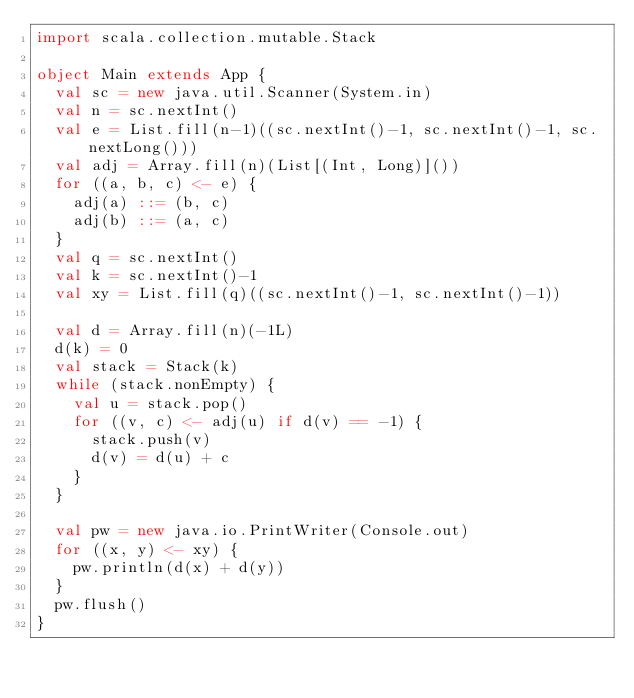Convert code to text. <code><loc_0><loc_0><loc_500><loc_500><_Scala_>import scala.collection.mutable.Stack

object Main extends App {
  val sc = new java.util.Scanner(System.in)
  val n = sc.nextInt()
  val e = List.fill(n-1)((sc.nextInt()-1, sc.nextInt()-1, sc.nextLong()))
  val adj = Array.fill(n)(List[(Int, Long)]())
  for ((a, b, c) <- e) {
    adj(a) ::= (b, c)
    adj(b) ::= (a, c)
  }
  val q = sc.nextInt()
  val k = sc.nextInt()-1
  val xy = List.fill(q)((sc.nextInt()-1, sc.nextInt()-1))

  val d = Array.fill(n)(-1L)
  d(k) = 0
  val stack = Stack(k)
  while (stack.nonEmpty) {
    val u = stack.pop()
    for ((v, c) <- adj(u) if d(v) == -1) {
      stack.push(v)
      d(v) = d(u) + c
    }
  }

  val pw = new java.io.PrintWriter(Console.out)
  for ((x, y) <- xy) {
    pw.println(d(x) + d(y))
  }
  pw.flush()
}
</code> 